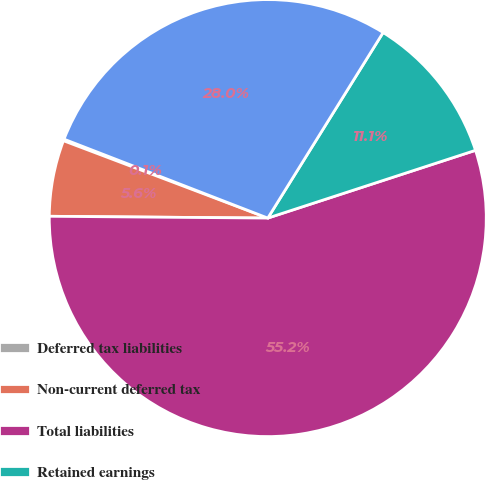Convert chart. <chart><loc_0><loc_0><loc_500><loc_500><pie_chart><fcel>Deferred tax liabilities<fcel>Non-current deferred tax<fcel>Total liabilities<fcel>Retained earnings<fcel>Total NASDAQ OMX stockholders'<nl><fcel>0.12%<fcel>5.63%<fcel>55.15%<fcel>11.13%<fcel>27.97%<nl></chart> 